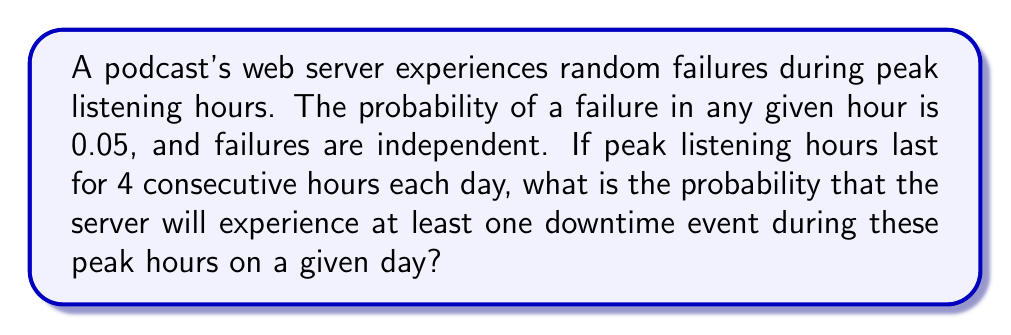Solve this math problem. Let's approach this step-by-step:

1) First, let's define our events:
   Let A be the event "server experiences at least one downtime during peak hours"

2) It's easier to calculate the probability of the complement of A, which is "server experiences no downtime during peak hours"

3) For no downtime to occur, the server must not fail in any of the 4 peak hours

4) The probability of no failure in a single hour is:
   $P(\text{no failure in 1 hour}) = 1 - 0.05 = 0.95$

5) Since the failures are independent, we can multiply the probabilities:
   $P(\text{no failure in 4 hours}) = 0.95^4$

6) Now, we can calculate the probability of at least one failure:
   $$\begin{align}
   P(A) &= 1 - P(\text{no failure in 4 hours}) \\
        &= 1 - 0.95^4 \\
        &= 1 - 0.8145 \\
        &= 0.1855
   \end{align}$$

7) Therefore, the probability of at least one server downtime during peak hours is approximately 0.1855 or 18.55%
Answer: $0.1855$ 